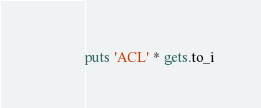<code> <loc_0><loc_0><loc_500><loc_500><_Ruby_>puts 'ACL' * gets.to_i</code> 